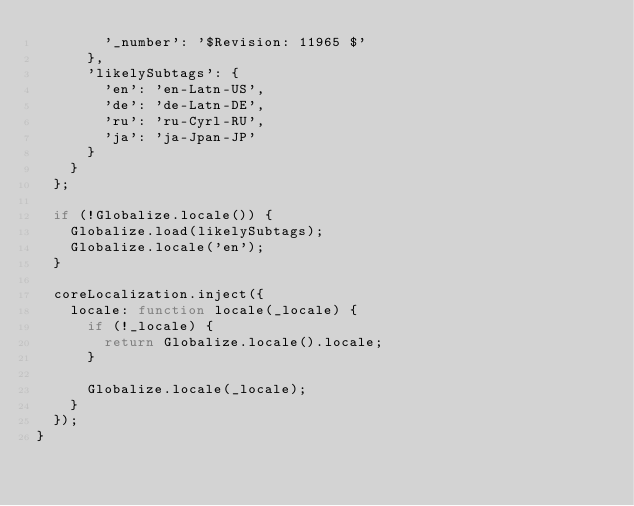<code> <loc_0><loc_0><loc_500><loc_500><_JavaScript_>        '_number': '$Revision: 11965 $'
      },
      'likelySubtags': {
        'en': 'en-Latn-US',
        'de': 'de-Latn-DE',
        'ru': 'ru-Cyrl-RU',
        'ja': 'ja-Jpan-JP'
      }
    }
  };

  if (!Globalize.locale()) {
    Globalize.load(likelySubtags);
    Globalize.locale('en');
  }

  coreLocalization.inject({
    locale: function locale(_locale) {
      if (!_locale) {
        return Globalize.locale().locale;
      }

      Globalize.locale(_locale);
    }
  });
}</code> 